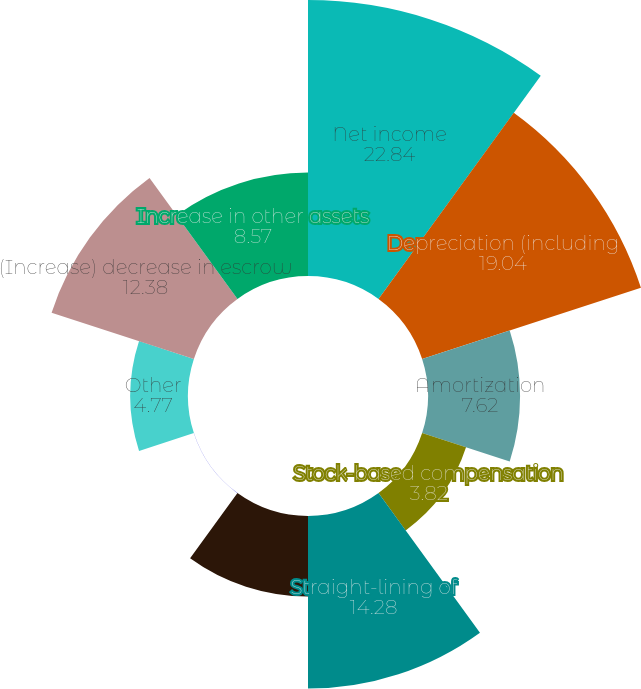<chart> <loc_0><loc_0><loc_500><loc_500><pie_chart><fcel>Net income<fcel>Depreciation (including<fcel>Amortization<fcel>Stock-based compensation<fcel>Straight-lining of<fcel>Amortization ofdeferred<fcel>Loss on extinguishment ofdebt<fcel>Other<fcel>(Increase) decrease in escrow<fcel>Increase in other assets<nl><fcel>22.84%<fcel>19.04%<fcel>7.62%<fcel>3.82%<fcel>14.28%<fcel>6.67%<fcel>0.01%<fcel>4.77%<fcel>12.38%<fcel>8.57%<nl></chart> 